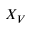Convert formula to latex. <formula><loc_0><loc_0><loc_500><loc_500>X _ { V }</formula> 